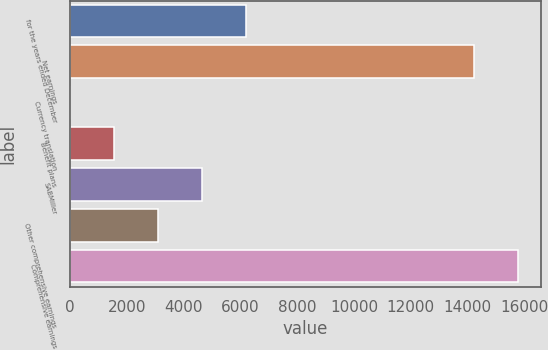Convert chart. <chart><loc_0><loc_0><loc_500><loc_500><bar_chart><fcel>for the years ended December<fcel>Net earnings<fcel>Currency translation<fcel>Benefit plans<fcel>SABMiller<fcel>Other comprehensive earnings<fcel>Comprehensive earnings<nl><fcel>6189.4<fcel>14244<fcel>1<fcel>1548.1<fcel>4642.3<fcel>3095.2<fcel>15791.1<nl></chart> 